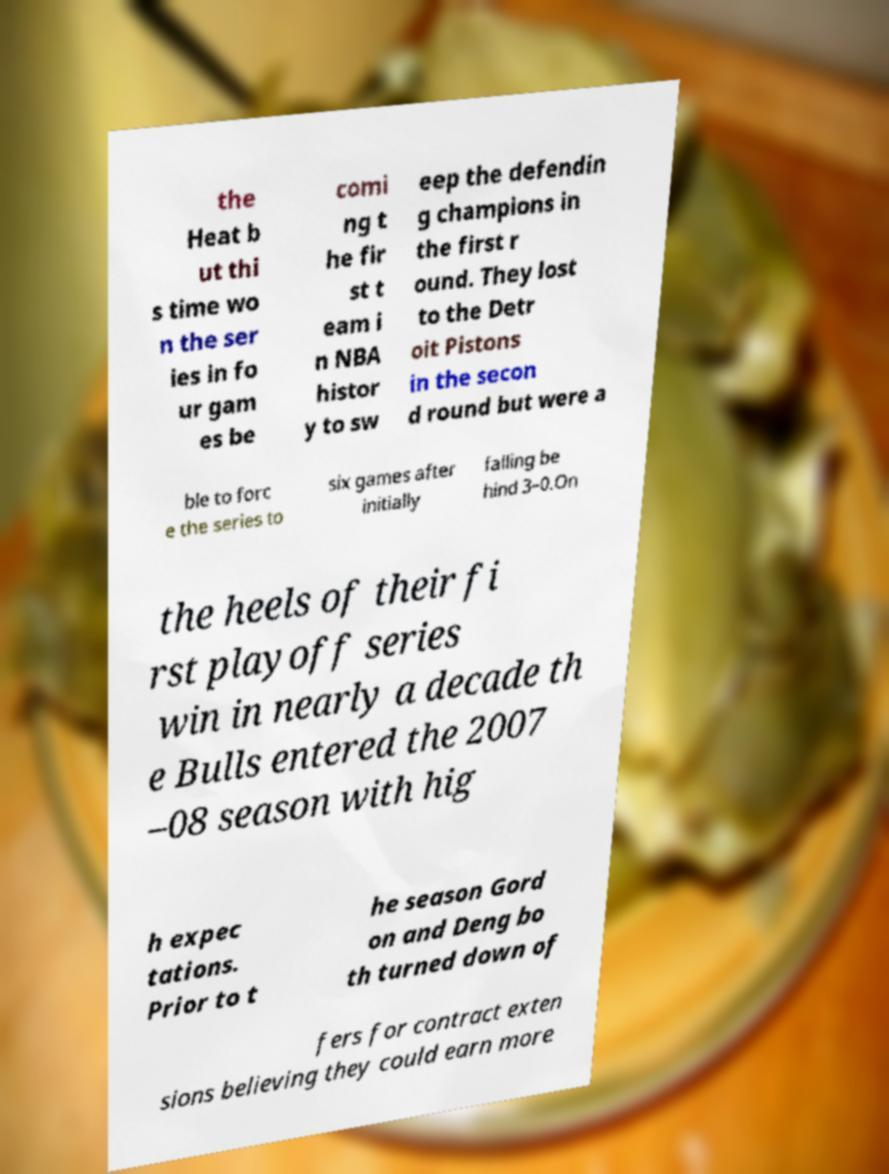For documentation purposes, I need the text within this image transcribed. Could you provide that? the Heat b ut thi s time wo n the ser ies in fo ur gam es be comi ng t he fir st t eam i n NBA histor y to sw eep the defendin g champions in the first r ound. They lost to the Detr oit Pistons in the secon d round but were a ble to forc e the series to six games after initially falling be hind 3–0.On the heels of their fi rst playoff series win in nearly a decade th e Bulls entered the 2007 –08 season with hig h expec tations. Prior to t he season Gord on and Deng bo th turned down of fers for contract exten sions believing they could earn more 